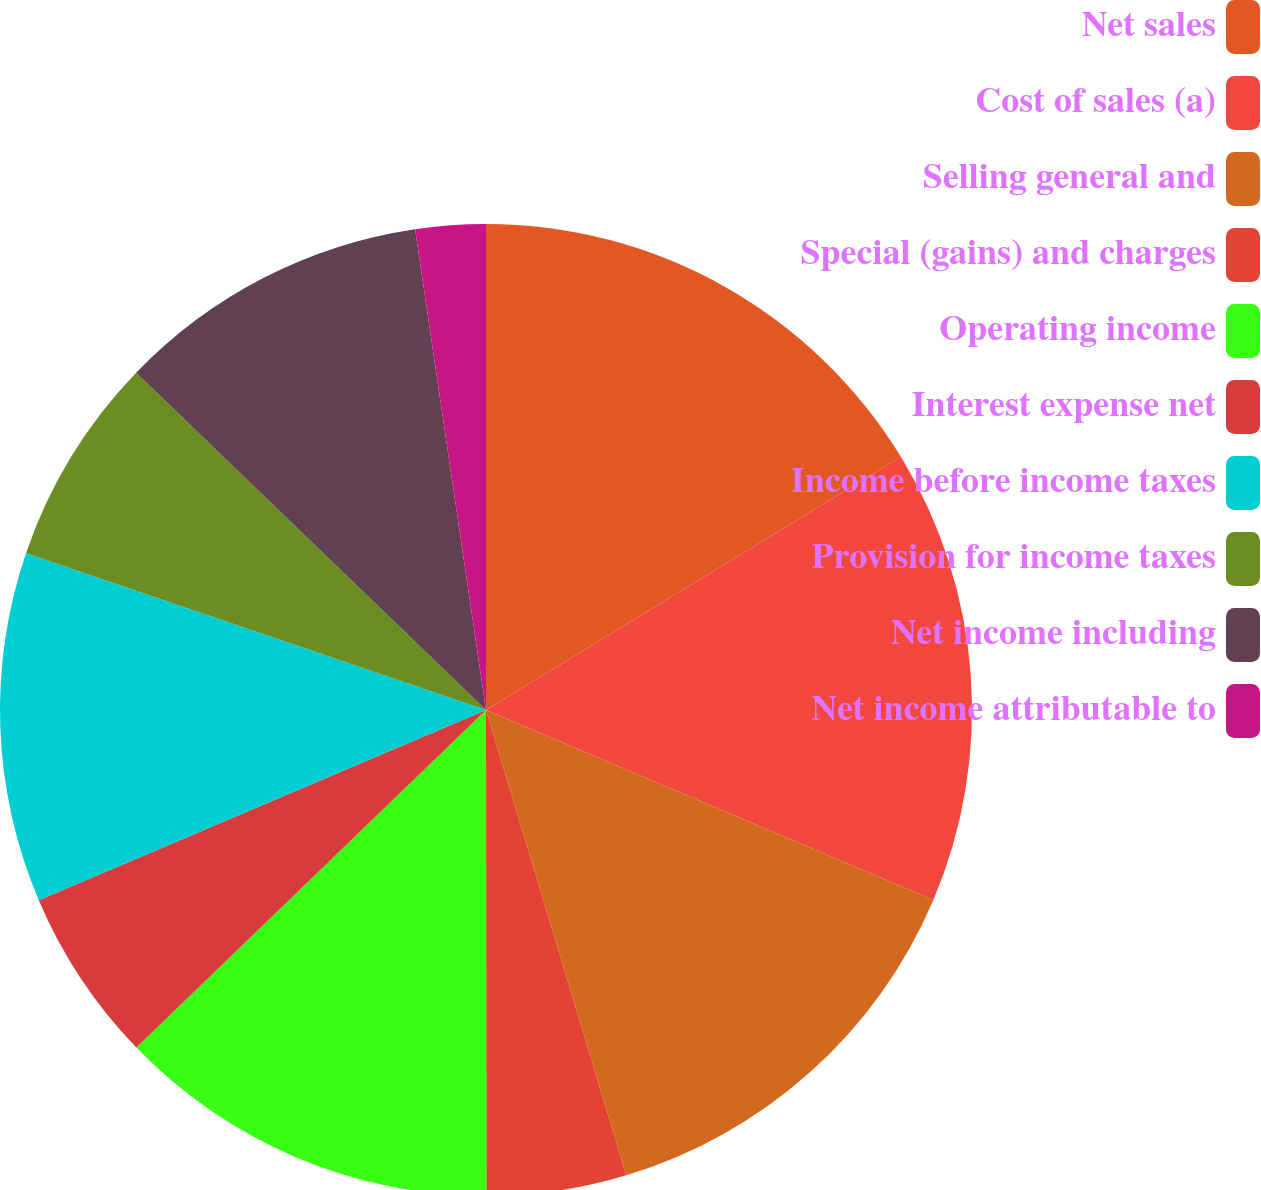<chart> <loc_0><loc_0><loc_500><loc_500><pie_chart><fcel>Net sales<fcel>Cost of sales (a)<fcel>Selling general and<fcel>Special (gains) and charges<fcel>Operating income<fcel>Interest expense net<fcel>Income before income taxes<fcel>Provision for income taxes<fcel>Net income including<fcel>Net income attributable to<nl><fcel>16.28%<fcel>15.11%<fcel>13.95%<fcel>4.65%<fcel>12.79%<fcel>5.82%<fcel>11.63%<fcel>6.98%<fcel>10.46%<fcel>2.33%<nl></chart> 